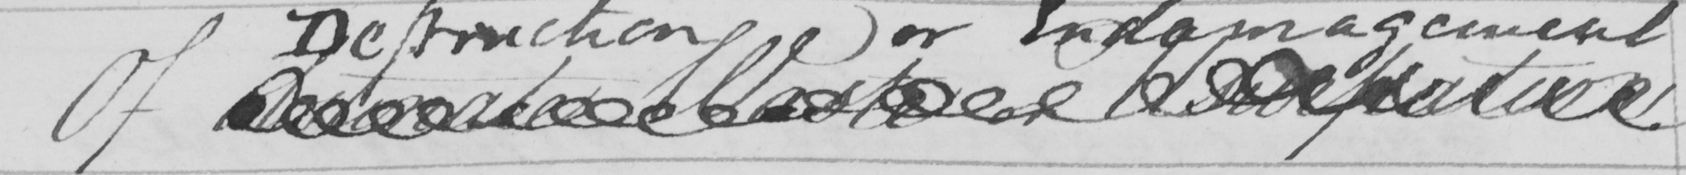What does this handwritten line say? Of Obstinate Waste or Usurpation 